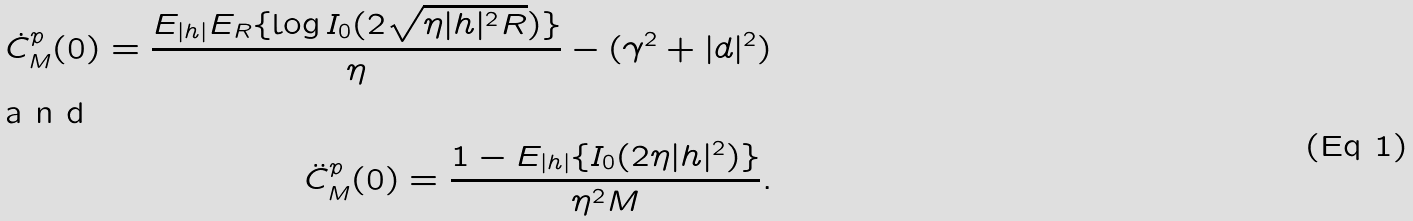<formula> <loc_0><loc_0><loc_500><loc_500>\dot { C } _ { M } ^ { p } ( 0 ) = \frac { E _ { | h | } E _ { R } \{ \log I _ { 0 } ( 2 \sqrt { \eta | h | ^ { 2 } R } ) \} } { \eta } - ( \gamma ^ { 2 } + | d | ^ { 2 } ) \intertext { a n d } \ddot { C } _ { M } ^ { p } ( 0 ) = \frac { 1 - E _ { | h | } \{ I _ { 0 } ( 2 \eta | h | ^ { 2 } ) \} } { \eta ^ { 2 } M } .</formula> 